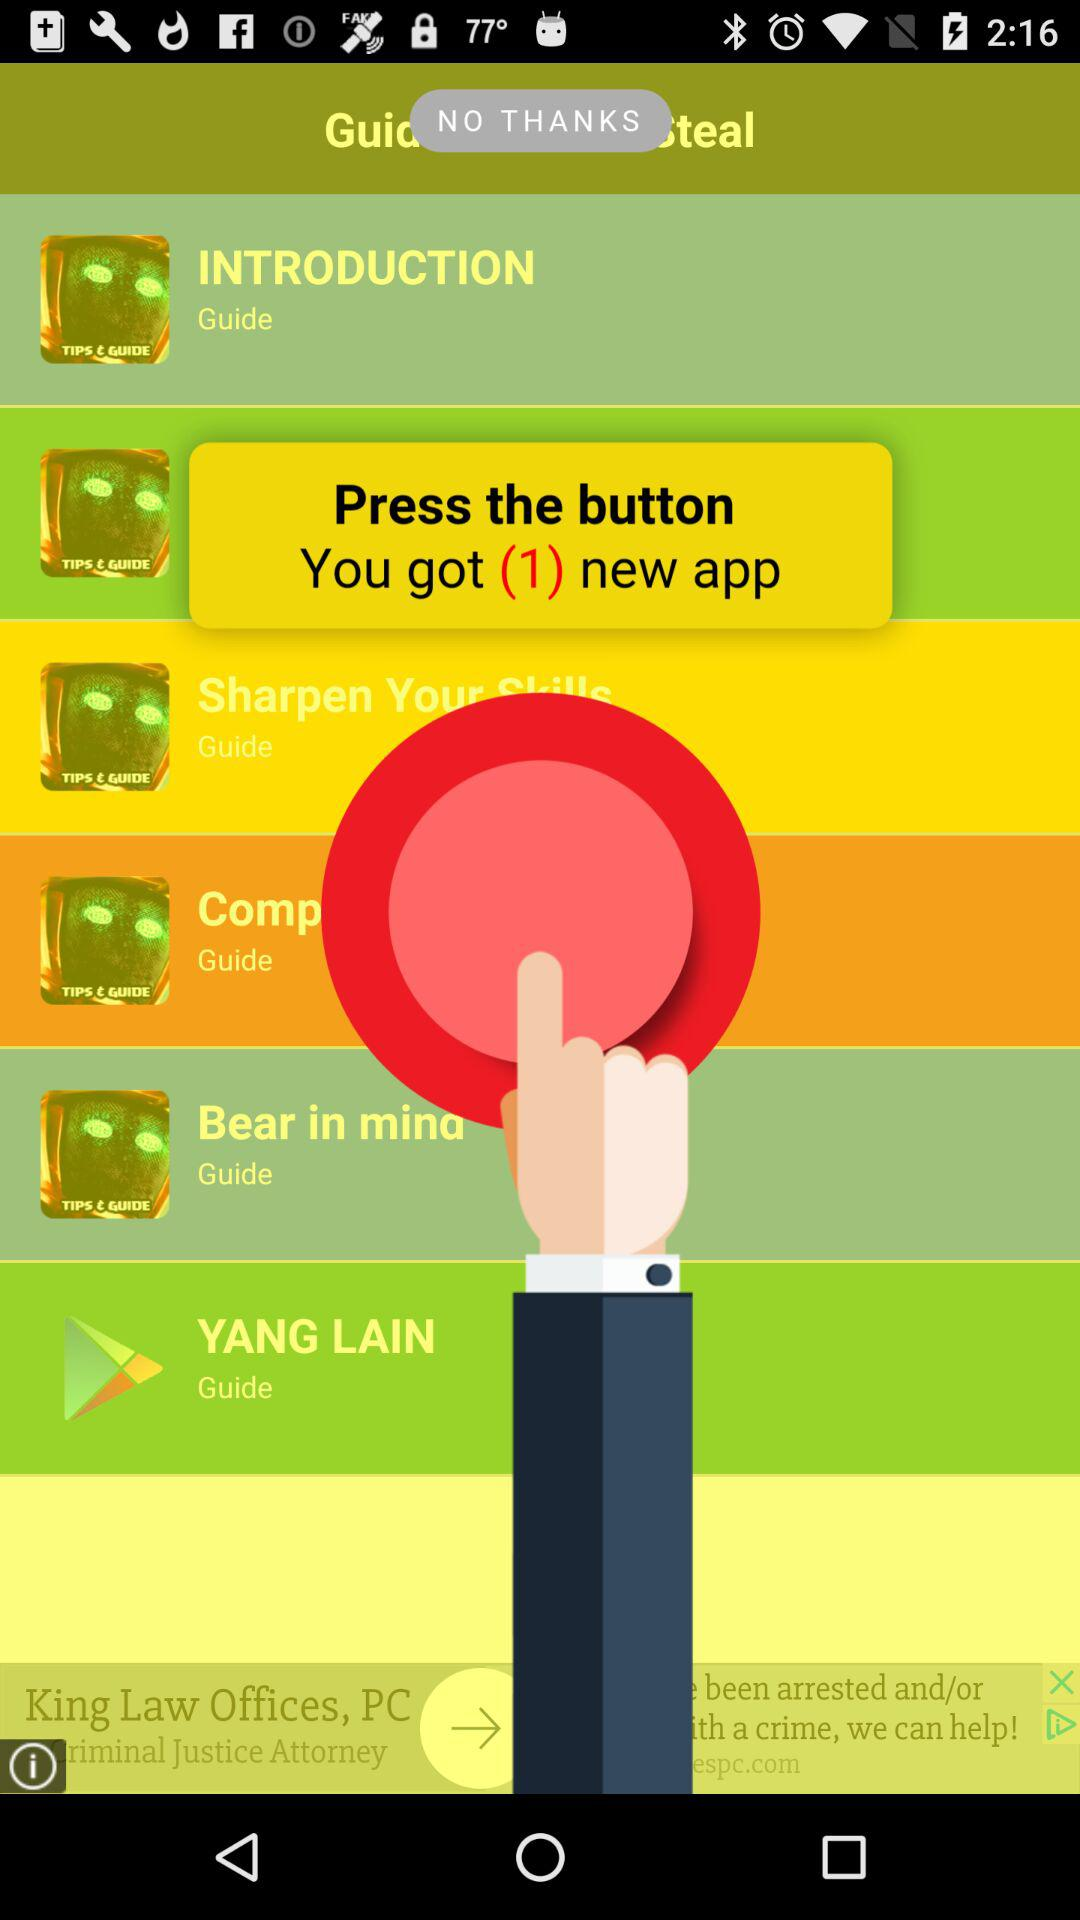How many new applications are there? There is 1 new application. 